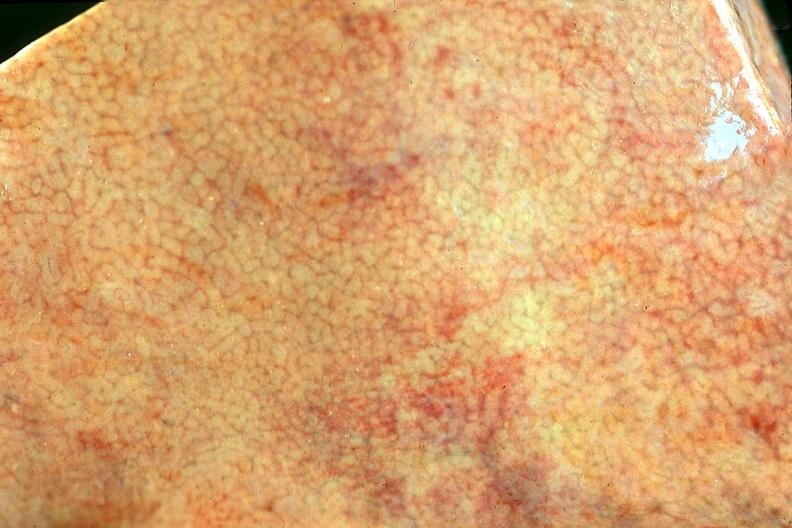does this image show normal liver?
Answer the question using a single word or phrase. Yes 